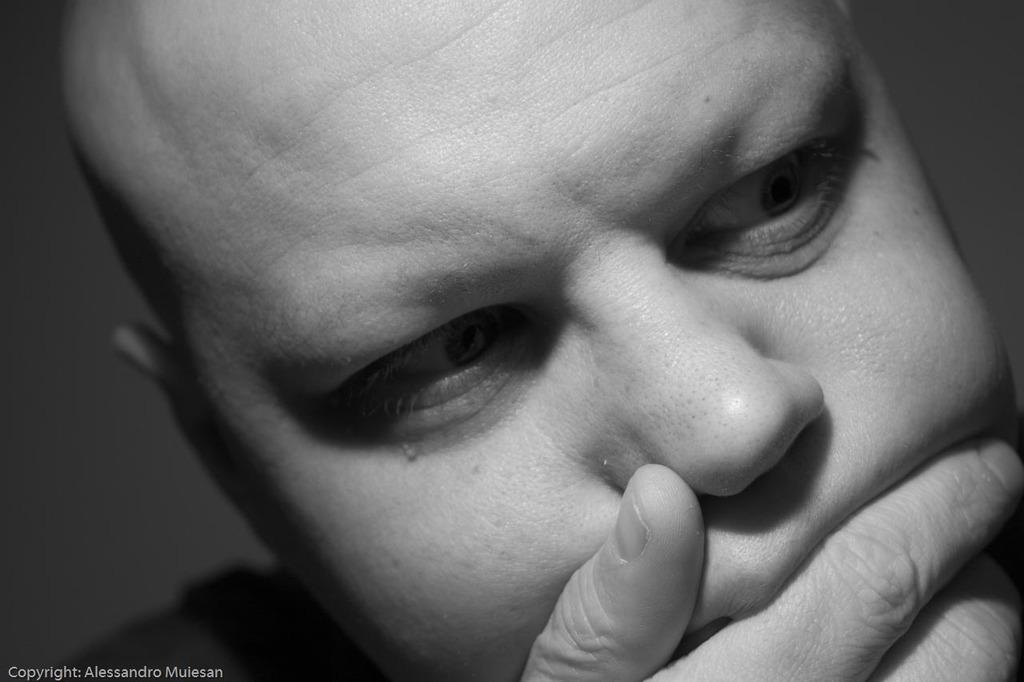What is the color scheme of the image? The image is black and white. Can you describe the main subject of the image? There is a man in the image. Is there any text present in the image? Yes, there is some text in the bottom left corner of the image. What type of stew is being prepared in the image? There is no stew present in the image; it is a black and white image featuring a man and some text. How many people are walking in the image? There are no people walking in the image; it only features a man standing still. 